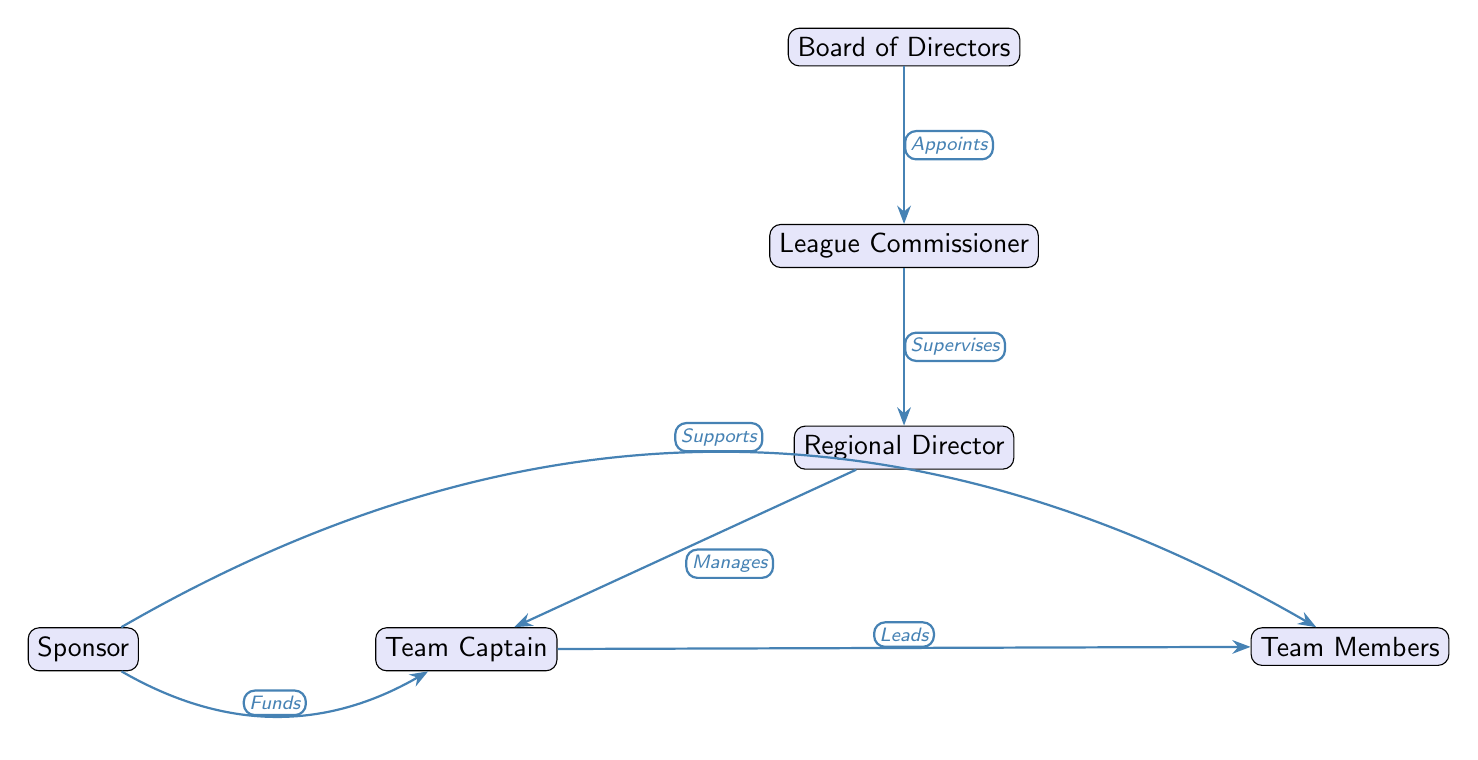What is the top node in the hierarchy? The topmost node in the diagram represents the "Board of Directors," which indicates the highest authority in the league structure.
Answer: Board of Directors How many levels are there in the hierarchy? The diagram contains five distinct levels: Board of Directors, League Commissioner, Regional Director, Team Captain, and Team Members.
Answer: Five What is the relationship between the League Commissioner and the Regional Director? The diagram indicates that the League Commissioner supervises the Regional Director, establishing a directional authority between the two nodes.
Answer: Supervises Who funds the Team Captain? The diagram shows that the Sponsor provides funding to the Team Captain, indicating a supportive role.
Answer: Sponsor What role does the Regional Director play in relation to Team Members? The Regional Director manages the Team Captain, who in turn leads the Team Members, establishing an indirect relationship by management.
Answer: Manages How does the Sponsor support Team Members? According to the diagram, the Sponsor supports the Team Members, indicating that the financial backing extends to the players as well as the captain.
Answer: Supports Which node is directly connected to the Team Captain? The Team Captain has direct connections to the Team Members and the Sponsor, signifying collaboration with both groups.
Answer: Team Members, Sponsor What type of diagram is this? The diagram fits the category of a Social Science Diagram, detailing the hierarchical organization within a bowling league structure.
Answer: Social Science Diagram In which direction does the authority flow in the diagram? Authority flows downward, starting from the Board of Directors at the top and moving to the Team Members at the bottom, depicting a clear chain of command.
Answer: Downward 